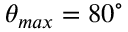<formula> <loc_0><loc_0><loc_500><loc_500>\theta _ { \max } = 8 0 ^ { \circ }</formula> 